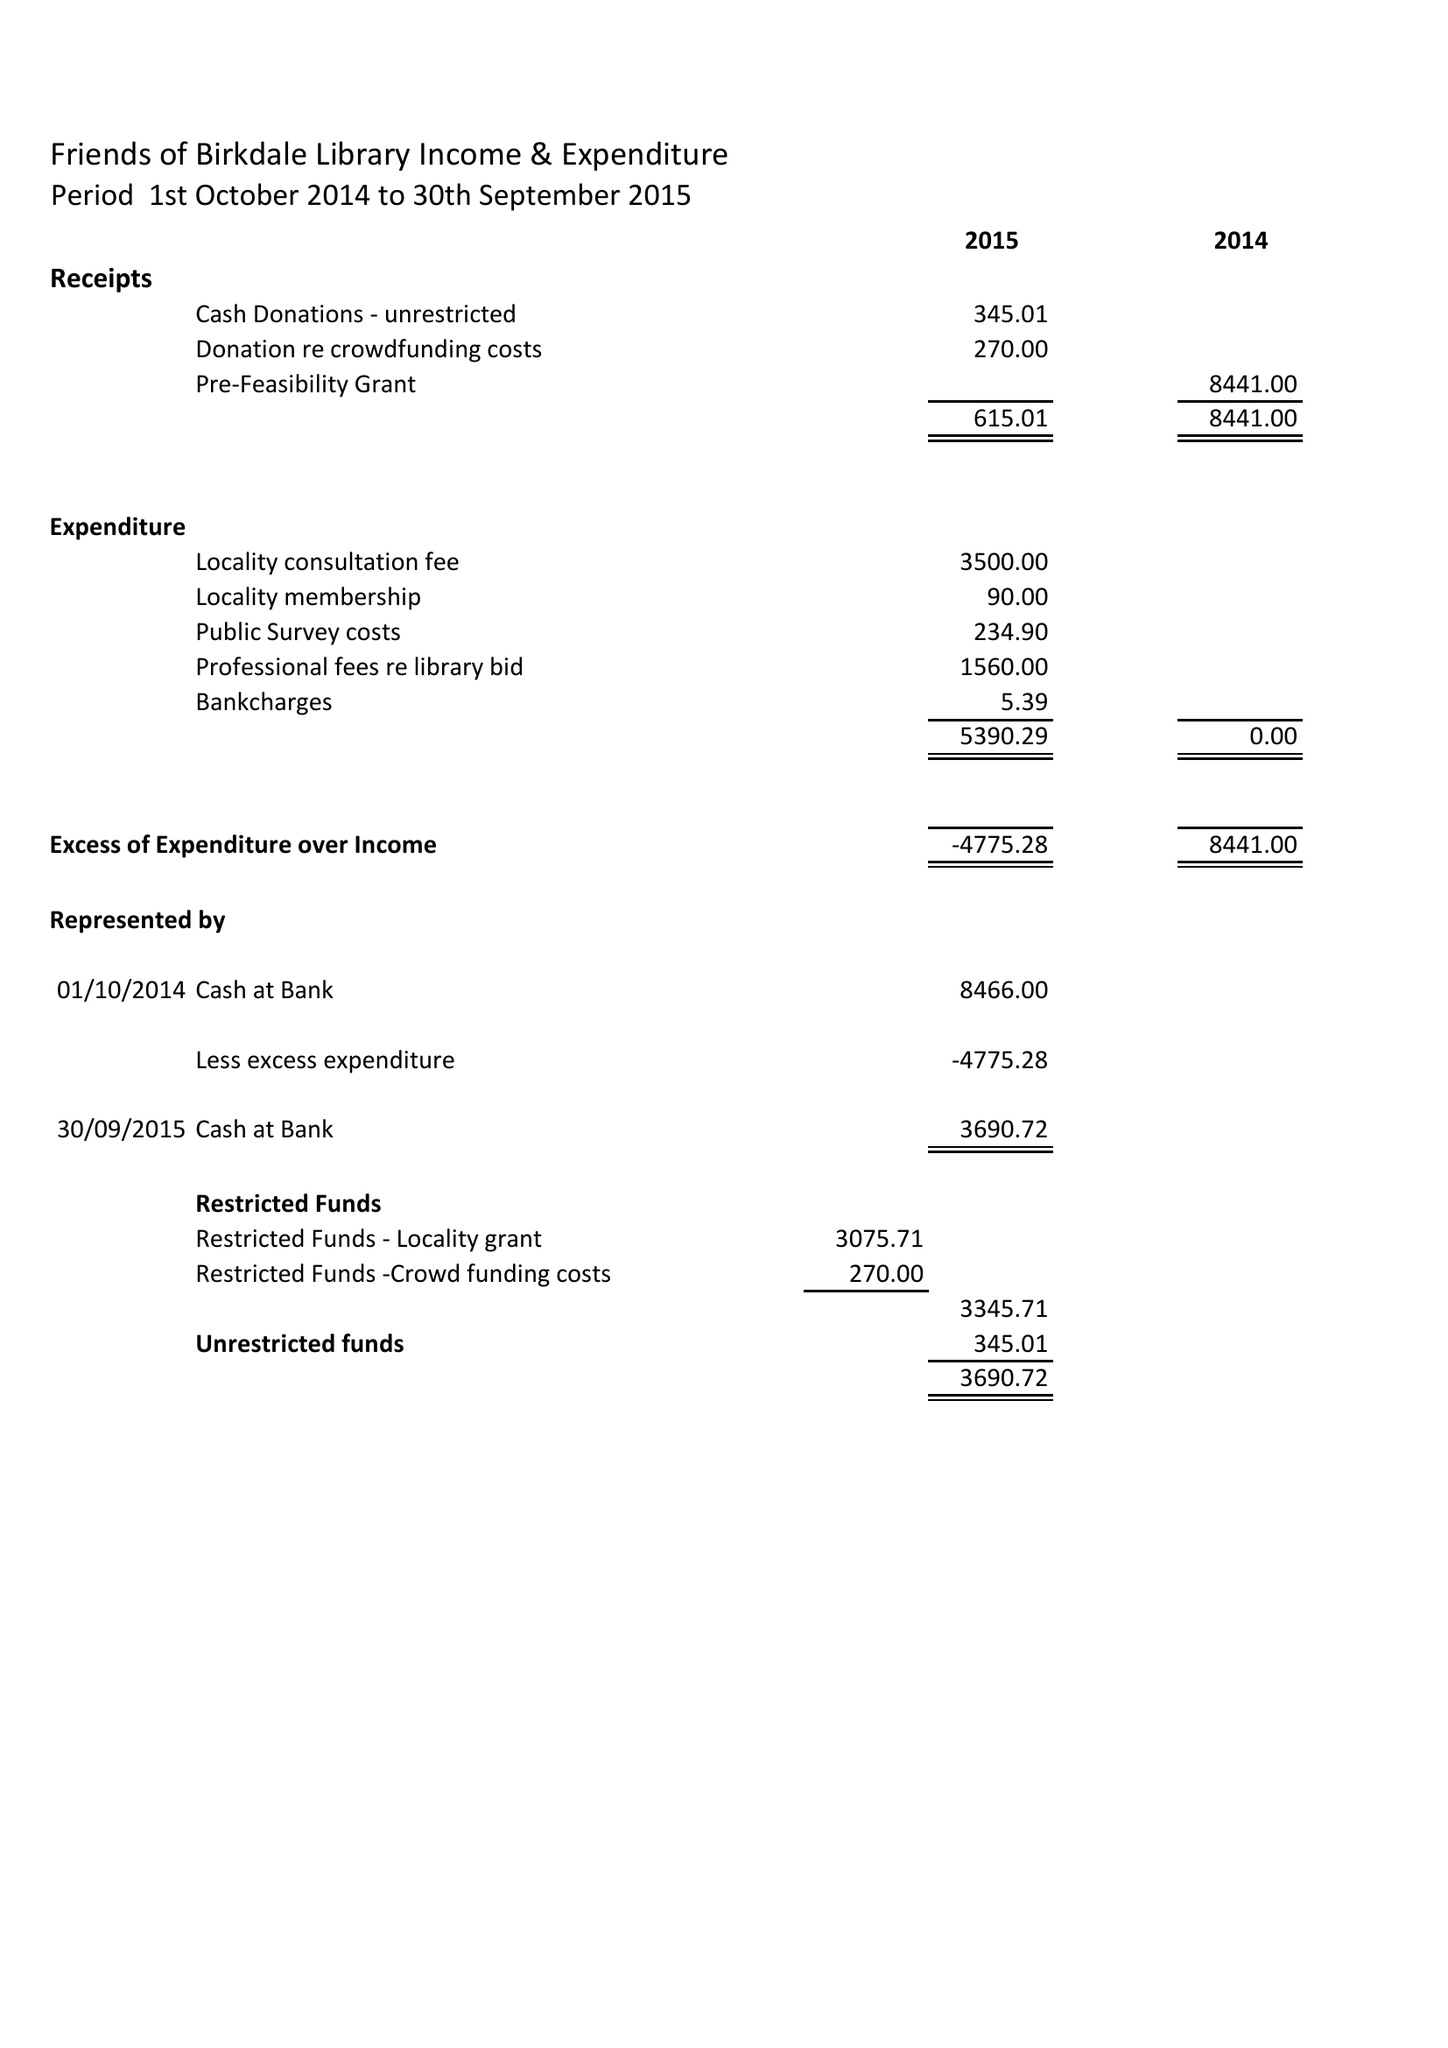What is the value for the address__post_town?
Answer the question using a single word or phrase. SOUTHPORT 